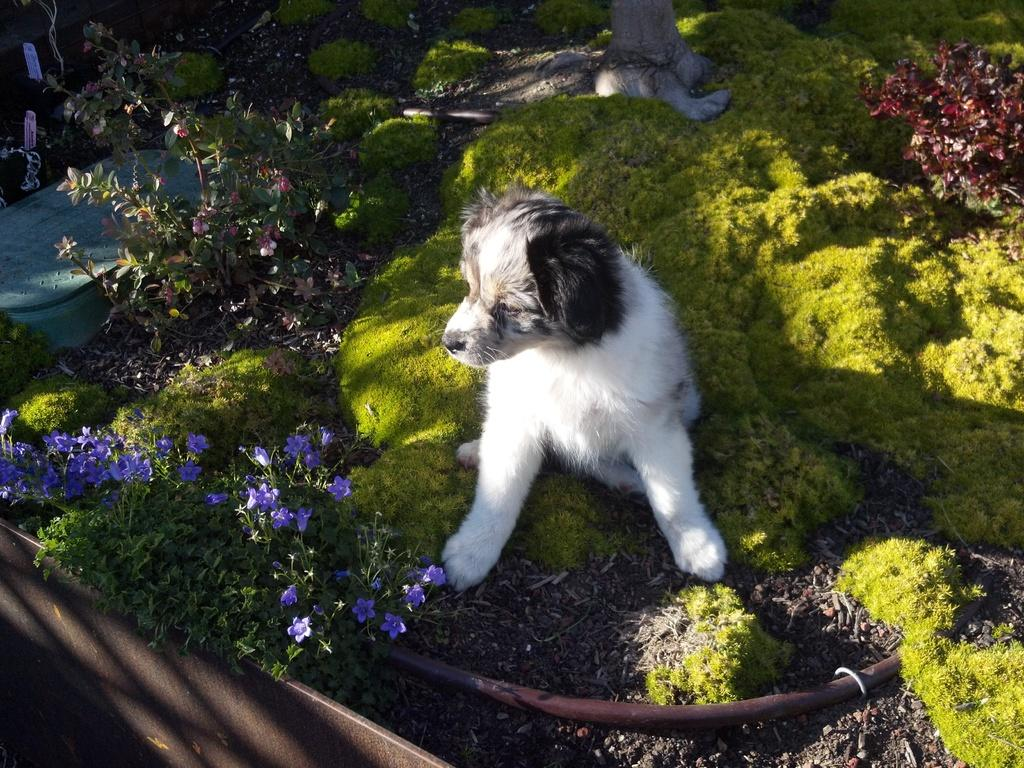What animal can be seen in the image? There is a dog in the image. Where is the dog located? The dog is sitting on the grass. What type of vegetation is present in the image? There are plants and flowers in the image. What type of furniture can be seen in the image? There is no furniture present in the image; it features a dog sitting on the grass with plants and flowers. What kind of paste is being used to create the flowers in the image? There is no paste or indication of any artificial creation of the flowers in the image; they appear to be real flowers. 